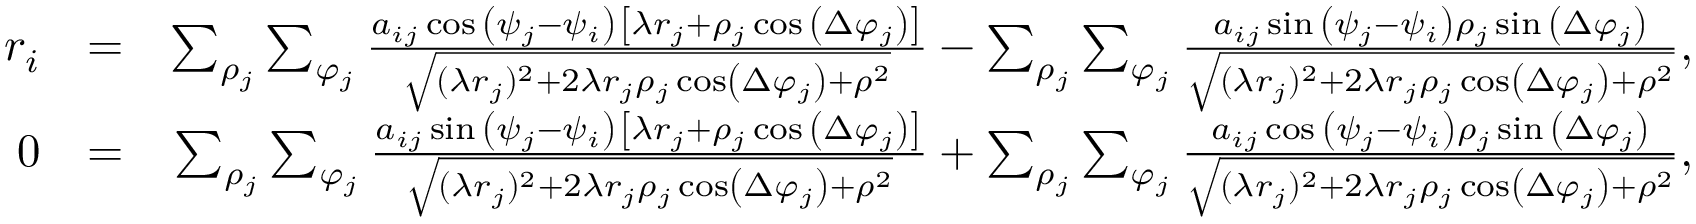Convert formula to latex. <formula><loc_0><loc_0><loc_500><loc_500>\begin{array} { r l r } { r _ { i } } & { = } & { \sum _ { \rho _ { j } } \sum _ { \varphi _ { j } } \frac { a _ { i j } \cos { \left ( \psi _ { j } - \psi _ { i } \right ) } \left [ \lambda r _ { j } + \rho _ { j } \cos { \left ( \Delta \varphi _ { j } \right ) } \right ] } { \sqrt { ( \lambda r _ { j } ) ^ { 2 } + 2 \lambda r _ { j } \rho _ { j } \cos \left ( \Delta \varphi _ { j } \right ) + \rho ^ { 2 } } } - \sum _ { \rho _ { j } } \sum _ { \varphi _ { j } } \frac { a _ { i j } \sin { \left ( \psi _ { j } - \psi _ { i } \right ) } \rho _ { j } \sin { \left ( \Delta \varphi _ { j } \right ) } } { \sqrt { ( \lambda r _ { j } ) ^ { 2 } + 2 \lambda r _ { j } \rho _ { j } \cos \left ( \Delta \varphi _ { j } \right ) + \rho ^ { 2 } } } , } \\ { 0 } & { = } & { \sum _ { \rho _ { j } } \sum _ { \varphi _ { j } } \frac { a _ { i j } \sin { \left ( \psi _ { j } - \psi _ { i } \right ) } \left [ \lambda r _ { j } + \rho _ { j } \cos { \left ( \Delta \varphi _ { j } \right ) } \right ] } { \sqrt { ( \lambda r _ { j } ) ^ { 2 } + 2 \lambda r _ { j } \rho _ { j } \cos \left ( \Delta \varphi _ { j } \right ) + \rho ^ { 2 } } } + \sum _ { \rho _ { j } } \sum _ { \varphi _ { j } } \frac { a _ { i j } \cos { \left ( \psi _ { j } - \psi _ { i } \right ) } \rho _ { j } \sin { \left ( \Delta \varphi _ { j } \right ) } } { \sqrt { ( \lambda r _ { j } ) ^ { 2 } + 2 \lambda r _ { j } \rho _ { j } \cos \left ( \Delta \varphi _ { j } \right ) + \rho ^ { 2 } } } , } \end{array}</formula> 